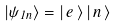Convert formula to latex. <formula><loc_0><loc_0><loc_500><loc_500>\left | \psi _ { 1 n } \right \rangle = \left | \, e \, \right \rangle \left | \, n \, \right \rangle</formula> 